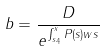<formula> <loc_0><loc_0><loc_500><loc_500>b = \frac { D } { e ^ { \int _ { s _ { 4 } } ^ { x } P ( s ) w s } }</formula> 